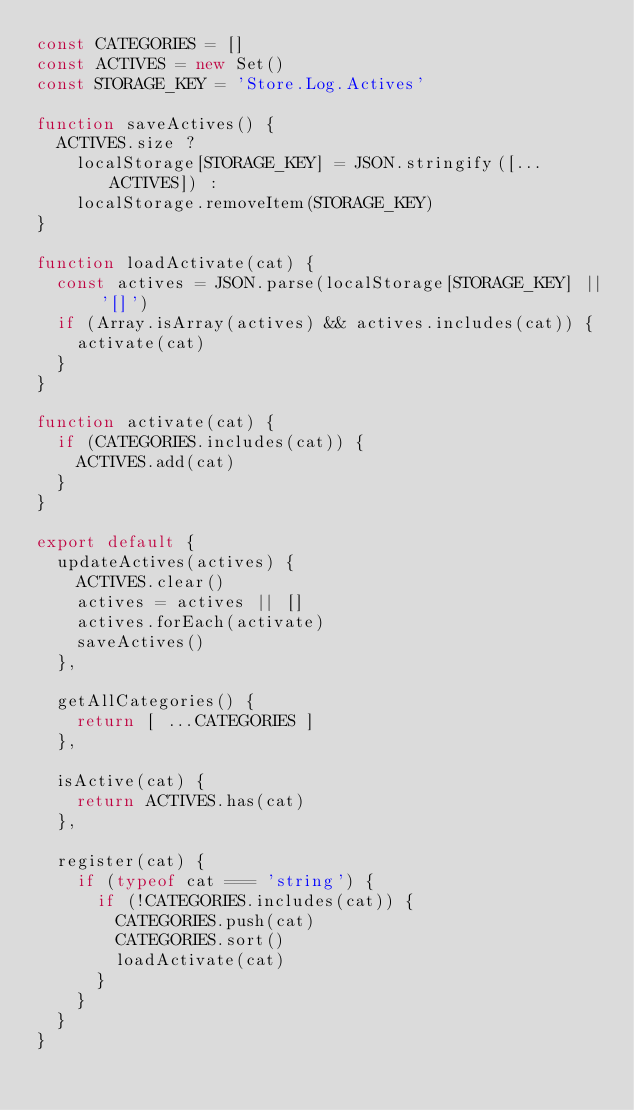<code> <loc_0><loc_0><loc_500><loc_500><_JavaScript_>const CATEGORIES = []
const ACTIVES = new Set()
const STORAGE_KEY = 'Store.Log.Actives'

function saveActives() {
  ACTIVES.size ?
    localStorage[STORAGE_KEY] = JSON.stringify([...ACTIVES]) :
    localStorage.removeItem(STORAGE_KEY)
}

function loadActivate(cat) {
  const actives = JSON.parse(localStorage[STORAGE_KEY] || '[]')
  if (Array.isArray(actives) && actives.includes(cat)) {
    activate(cat)
  }
}

function activate(cat) {
  if (CATEGORIES.includes(cat)) {
    ACTIVES.add(cat)
  }
}

export default {
  updateActives(actives) {
    ACTIVES.clear()
    actives = actives || []
    actives.forEach(activate)
    saveActives()
  },

  getAllCategories() {
    return [ ...CATEGORIES ]
  },

  isActive(cat) {
    return ACTIVES.has(cat)
  },

  register(cat) {
    if (typeof cat === 'string') {
      if (!CATEGORIES.includes(cat)) {
        CATEGORIES.push(cat)
        CATEGORIES.sort()
        loadActivate(cat)
      }
    }
  }
}</code> 